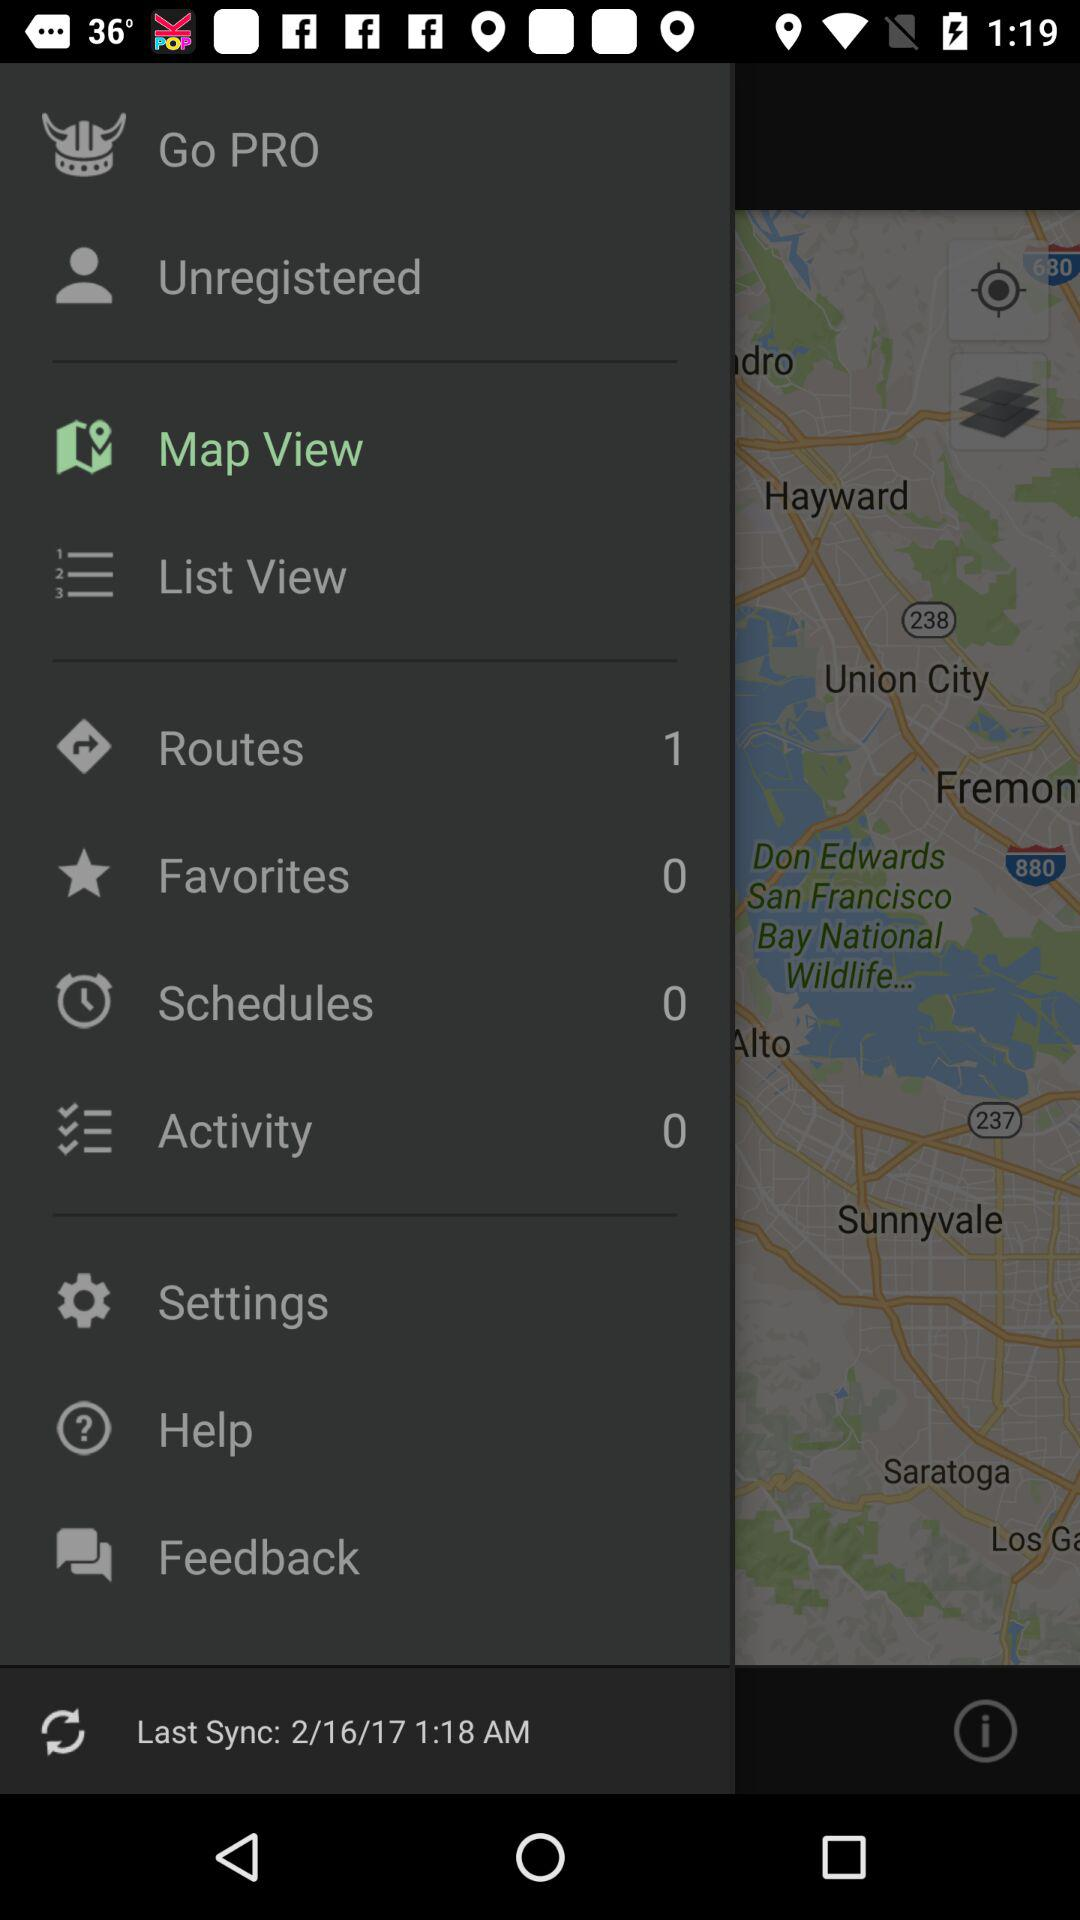What is the number of routes? The number of routes is 1. 